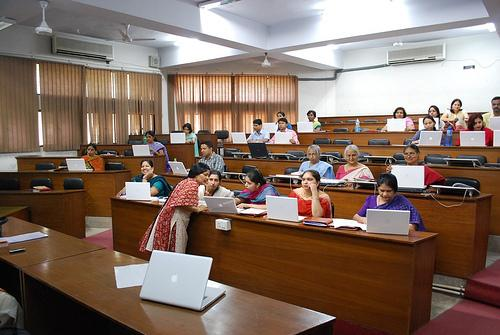Which country is this class most likely taught in? Please explain your reasoning. india. The students are all indian. 